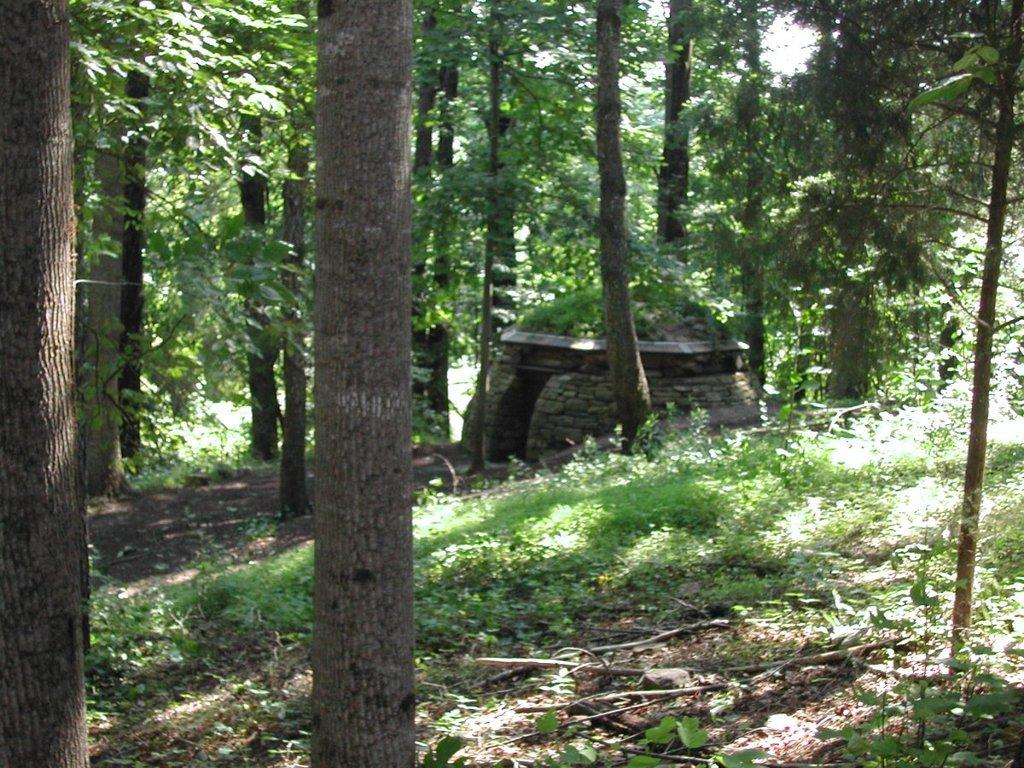What type of natural elements can be seen in the image? There are trees, rocks, and plants in the image. Can you describe the landscape in the image? The landscape in the image includes trees, rocks, and plants. What might be the setting of the image? The setting of the image might be a natural environment, such as a park or a forest. What type of apparatus is being used by the beginner in the image? There is no apparatus or beginner present in the image; it features trees, rocks, and plants. Can you tell me how many faces can be seen in the image? There are no faces present in the image; it features trees, rocks, and plants. 